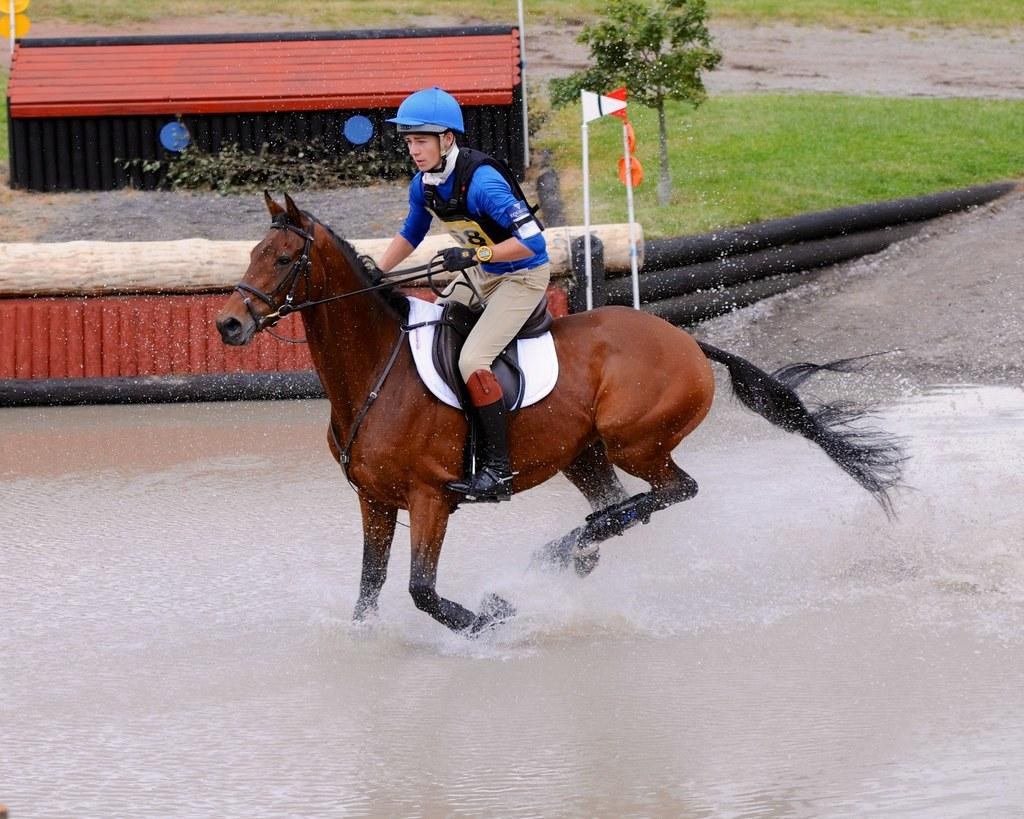What is the person in the image doing? The person is riding a horse in the image. Where is the horse located? The horse is on the water in the image. What can be seen behind the horse? There are wooden logs and poles with boards behind the horse. What type of vegetation is visible in the image? There is a plant and grass present in the image. What is the unspecified object in the image? Unfortunately, the facts provided do not specify the nature of the unspecified object. What type of shoes is the person wearing while riding the horse in the image? There is no information about the person's shoes in the image, so we cannot determine what type they are wearing. Can you tell me the income of the squirrel in the image? There is no squirrel present in the image, so we cannot determine its income. 